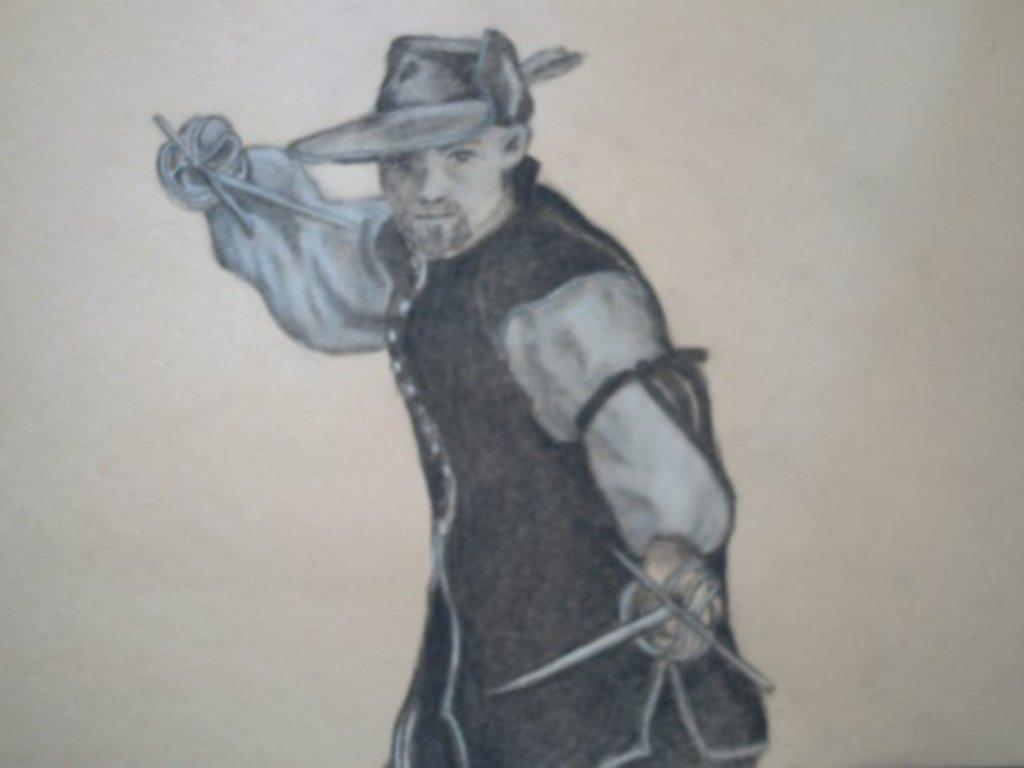Can you describe this image briefly? In this image I can see a painting of a person holding some objects in the hands. The background is in white color. 